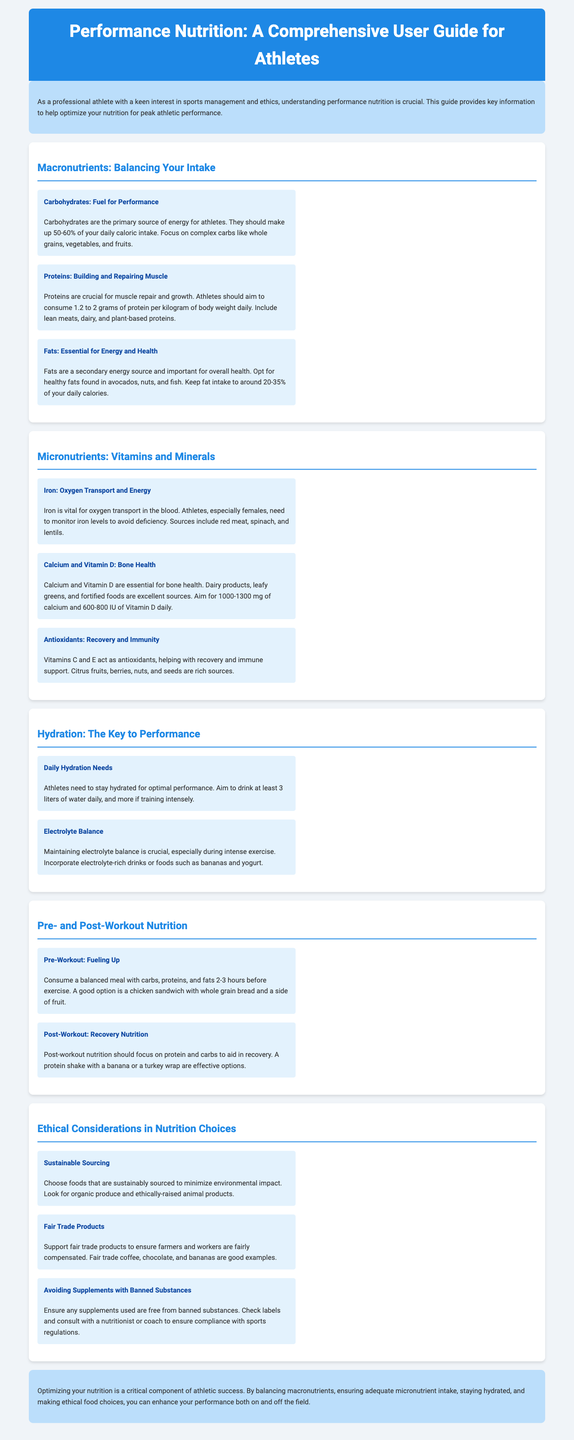What percentage of daily caloric intake should carbohydrates make up? The document states that carbohydrates should make up 50-60% of your daily caloric intake.
Answer: 50-60% How much protein should athletes consume per kilogram of body weight? The guide recommends that athletes aim to consume 1.2 to 2 grams of protein per kilogram of body weight daily.
Answer: 1.2 to 2 grams What is one good source of iron listed in the document? The document mentions that red meat, spinach, and lentils are sources of iron.
Answer: Red meat What is the daily hydration recommendation for athletes? The document suggests that athletes should aim to drink at least 3 liters of water daily.
Answer: 3 liters What should pre-workout nutrition include? It is recommended to consume a balanced meal with carbs, proteins, and fats 2-3 hours before exercise.
Answer: Balanced meal with carbs, proteins, and fats Which section discusses ethical considerations in nutrition choices? The section titled "Ethical Considerations in Nutrition Choices" addresses this topic.
Answer: Ethical Considerations in Nutrition Choices What is a key focus of post-workout nutrition? The guide emphasizes that post-workout nutrition should focus on protein and carbs to aid in recovery.
Answer: Protein and carbs What type of foods should athletes choose according to the ethical considerations? The document suggests choosing foods that are sustainably sourced.
Answer: Sustainably sourced foods What are athletes advised to check when using supplements? The guide advises ensuring any supplements used are free from banned substances.
Answer: Free from banned substances 